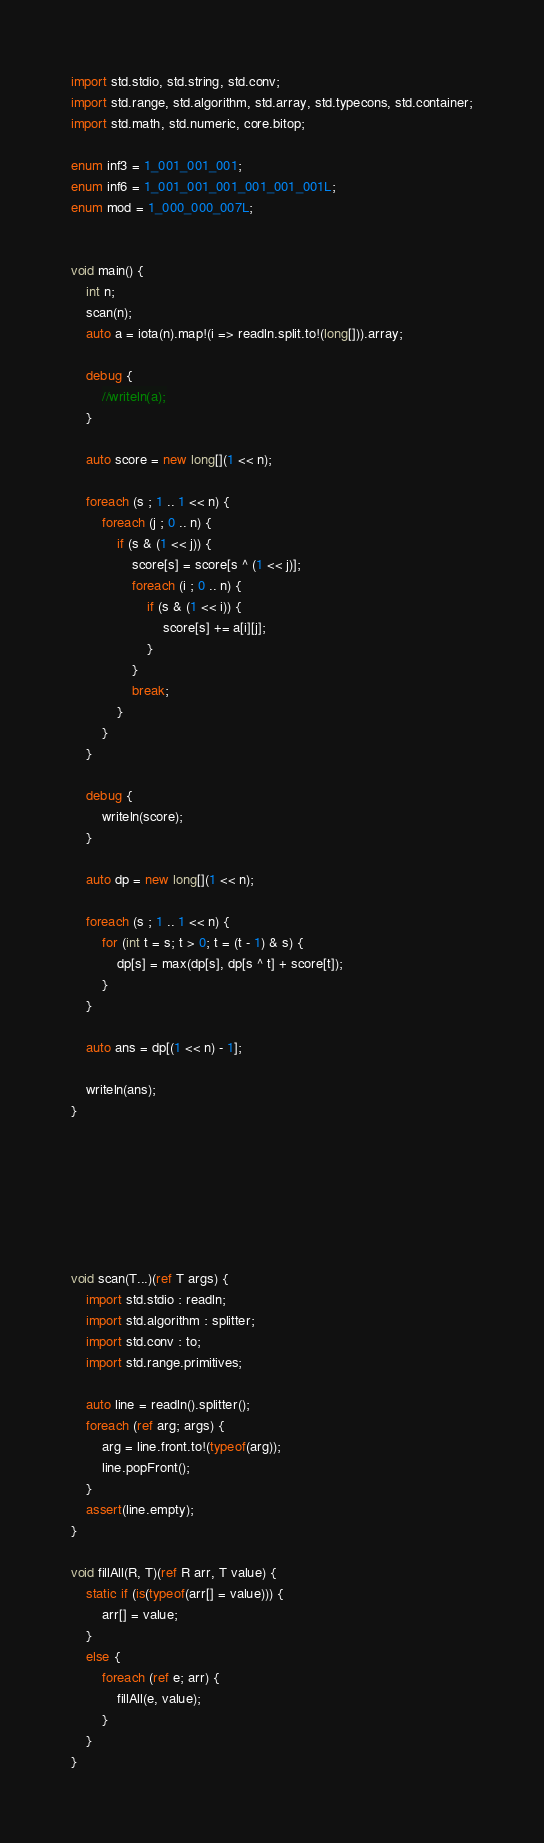<code> <loc_0><loc_0><loc_500><loc_500><_D_>import std.stdio, std.string, std.conv;
import std.range, std.algorithm, std.array, std.typecons, std.container;
import std.math, std.numeric, core.bitop;

enum inf3 = 1_001_001_001;
enum inf6 = 1_001_001_001_001_001_001L;
enum mod = 1_000_000_007L;


void main() {
    int n;
    scan(n);
    auto a = iota(n).map!(i => readln.split.to!(long[])).array;

    debug {
        //writeln(a);
    }

    auto score = new long[](1 << n);

    foreach (s ; 1 .. 1 << n) {
        foreach (j ; 0 .. n) {
            if (s & (1 << j)) {
                score[s] = score[s ^ (1 << j)];
                foreach (i ; 0 .. n) {
                    if (s & (1 << i)) {
                        score[s] += a[i][j];
                    }
                }
                break;
            }
        }
    }

    debug {
        writeln(score);
    }

    auto dp = new long[](1 << n);

    foreach (s ; 1 .. 1 << n) {
        for (int t = s; t > 0; t = (t - 1) & s) {
            dp[s] = max(dp[s], dp[s ^ t] + score[t]);
        }
    }

    auto ans = dp[(1 << n) - 1];

    writeln(ans);
}







void scan(T...)(ref T args) {
    import std.stdio : readln;
    import std.algorithm : splitter;
    import std.conv : to;
    import std.range.primitives;

    auto line = readln().splitter();
    foreach (ref arg; args) {
        arg = line.front.to!(typeof(arg));
        line.popFront();
    }
    assert(line.empty);
}

void fillAll(R, T)(ref R arr, T value) {
    static if (is(typeof(arr[] = value))) {
        arr[] = value;
    }
    else {
        foreach (ref e; arr) {
            fillAll(e, value);
        }
    }
}
</code> 